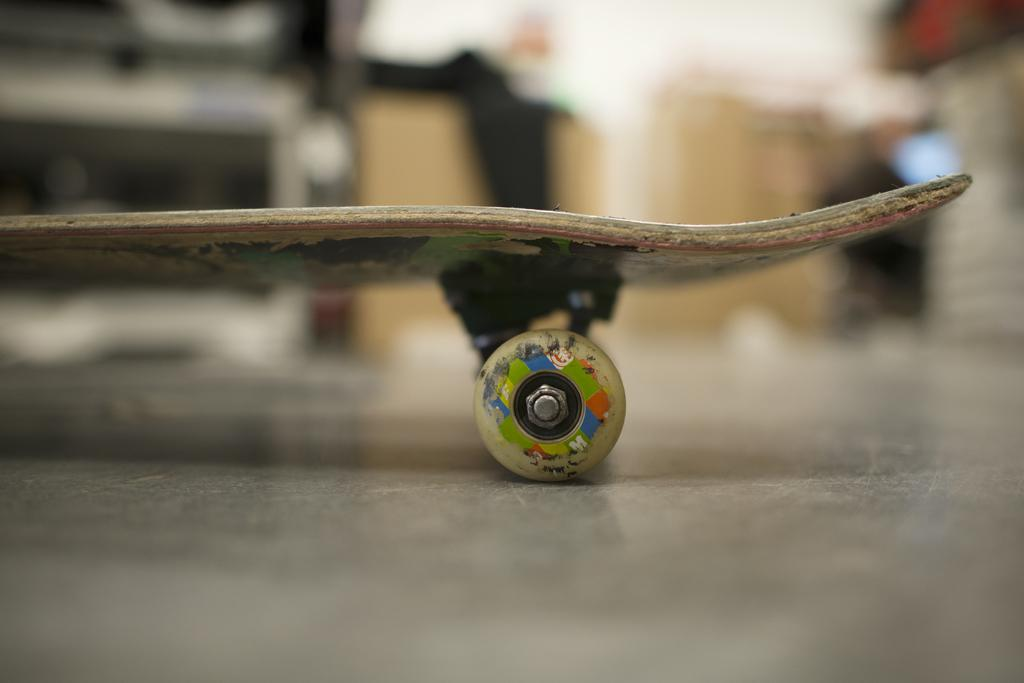What is the main object in the image? There is a skateboard in the image. Can you describe the background of the image? The background of the image is blurred. What type of reason can be seen in the image? There is no reason present in the image; it features a skateboard and a blurred background. Can you locate a map in the image? There is no map present in the image. 